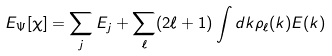Convert formula to latex. <formula><loc_0><loc_0><loc_500><loc_500>E _ { \Psi } [ \chi ] = \sum _ { j } E _ { j } + \sum _ { \ell } ( 2 \ell + 1 ) \int d k \rho _ { \ell } ( k ) E ( k )</formula> 